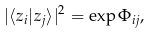<formula> <loc_0><loc_0><loc_500><loc_500>| \langle z _ { i } | z _ { j } \rangle | ^ { 2 } = \exp \Phi _ { i j } ,</formula> 